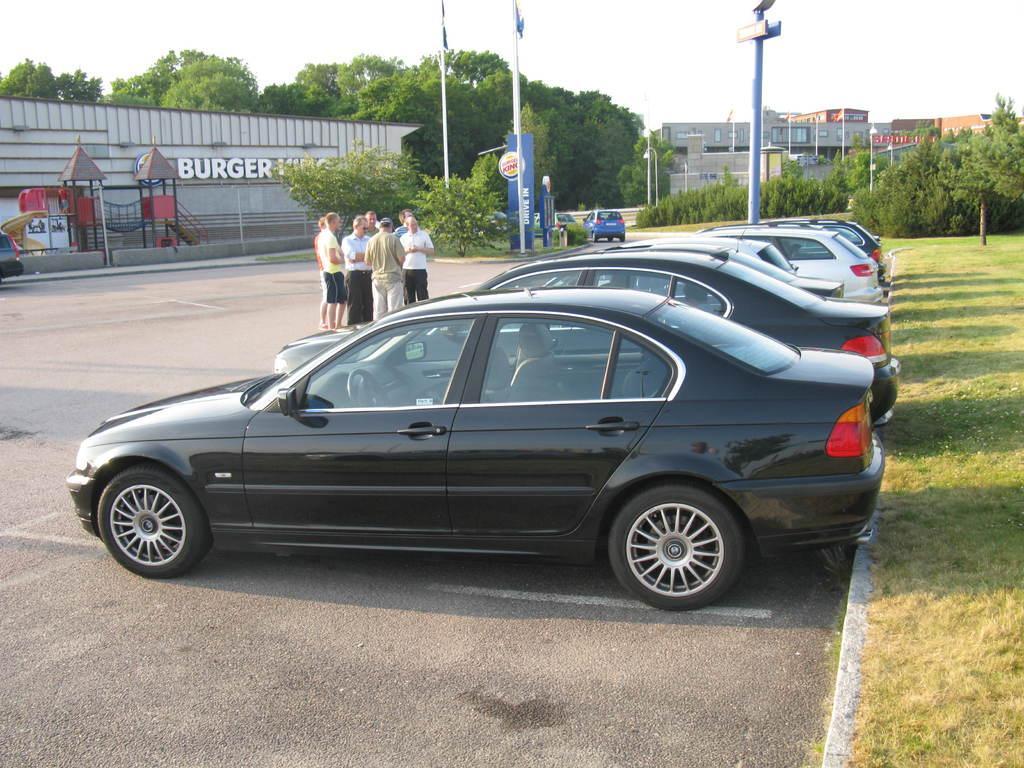In one or two sentences, can you explain what this image depicts? In this image I can see the road, few cars which are black and white in color on the ground, few persons standing, few trees, some grass, few poles, few boards and few buildings. In the background I can see the sky. 